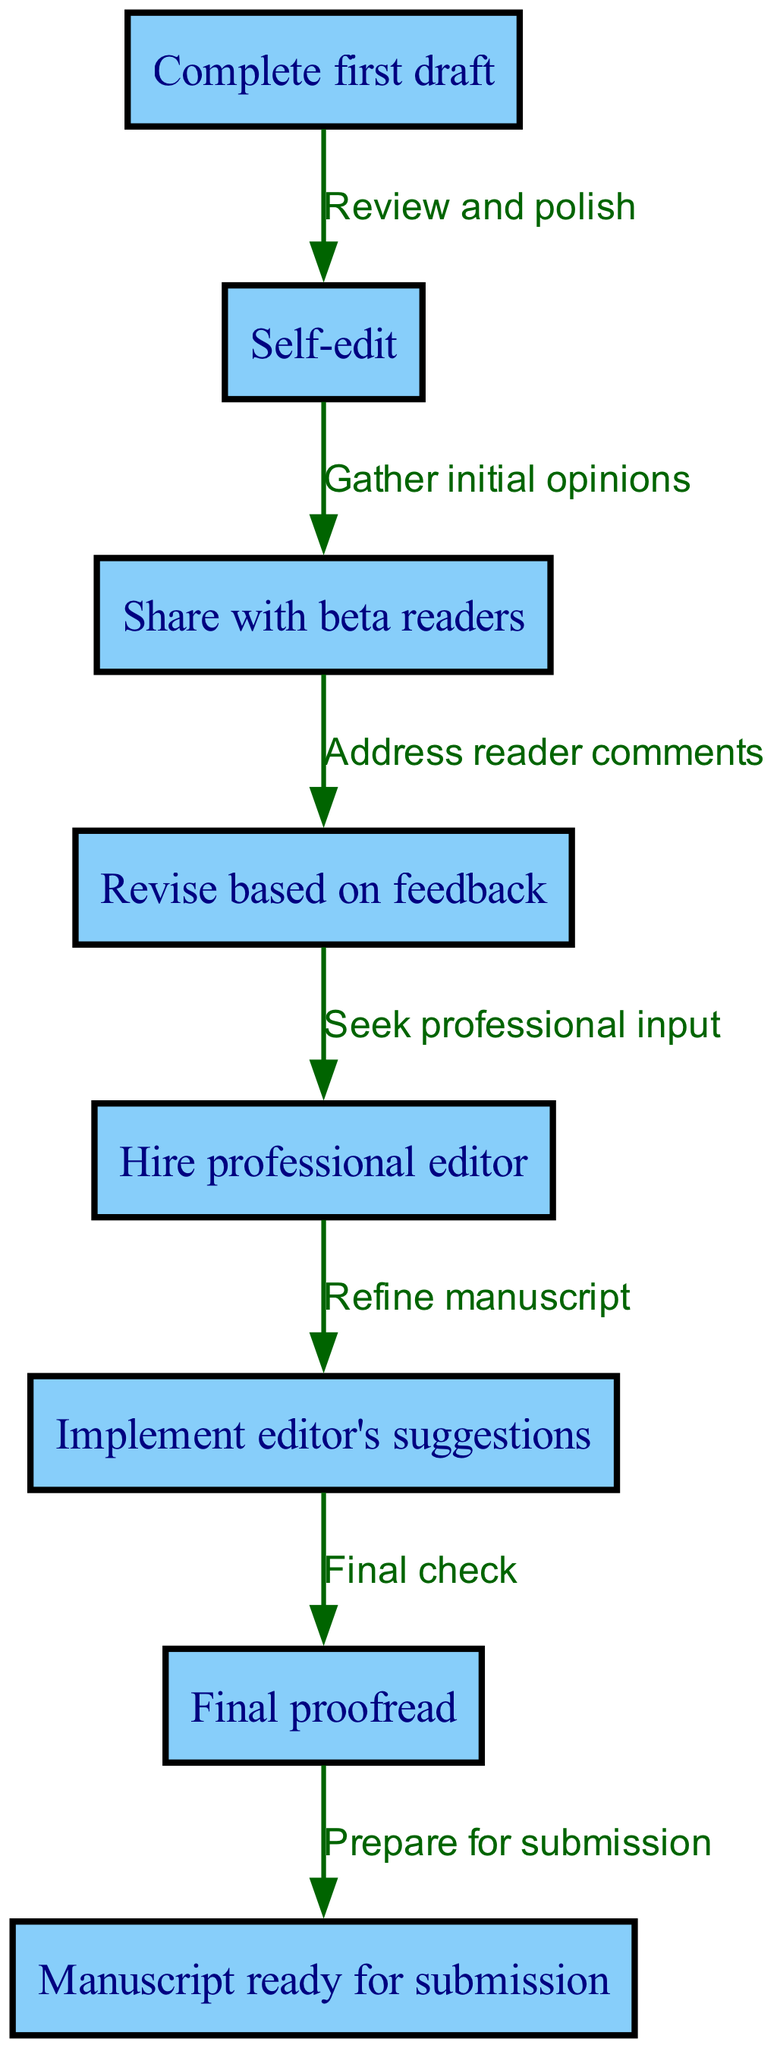What is the first step in the editing process? The first step shown in the diagram is "Complete first draft," which is the starting point of the editing and revision process.
Answer: Complete first draft How many nodes are there in the diagram? By counting all the distinct steps in the editing process, we see there are eight nodes labeled from one to eight, representing different stages.
Answer: Eight What follows self-editing in the process? According to the diagram, after self-editing, the next step is "Share with beta readers," which signifies gathering opinions on the manuscript.
Answer: Share with beta readers What action is taken after receiving feedback from beta readers? The diagram indicates that after sharing with beta readers, the next step is "Revise based on feedback," where the author adjusts the manuscript according to the comments received.
Answer: Revise based on feedback What is the significance of hiring a professional editor? The diagram shows that hiring a professional editor is a crucial step that comes after revising based on feedback, as it provides expert insights to further refine the manuscript.
Answer: Hire professional editor What is the final step before submitting the manuscript? The last node before submission is "Final proofread," which signifies the last opportunity to catch errors or make last-minute adjustments prior to submission.
Answer: Final proofread How many edges connect the nodes in the diagram? By examining the connections between the nodes, we find that there are seven edges that illustrate the flow of the editing process.
Answer: Seven What is the overall outcome after completing the entire process? According to the final node in the diagram, the outcome of completing all the steps is that the "Manuscript ready for submission," indicating that the manuscript is finalized and prepared to be sent out.
Answer: Manuscript ready for submission 